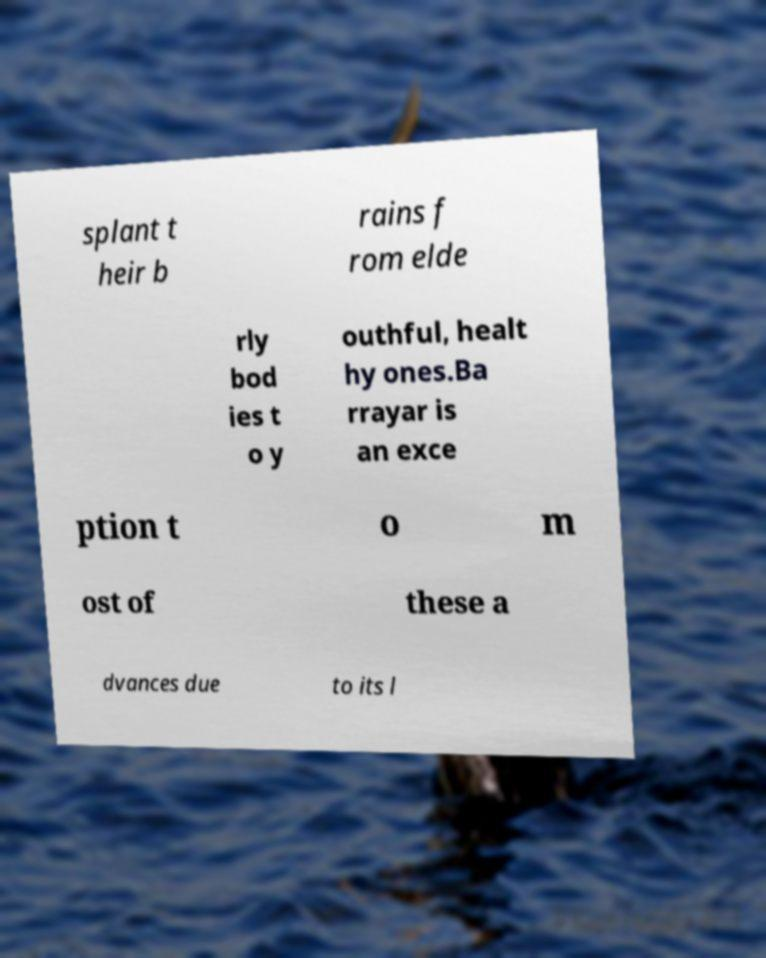Could you extract and type out the text from this image? splant t heir b rains f rom elde rly bod ies t o y outhful, healt hy ones.Ba rrayar is an exce ption t o m ost of these a dvances due to its l 